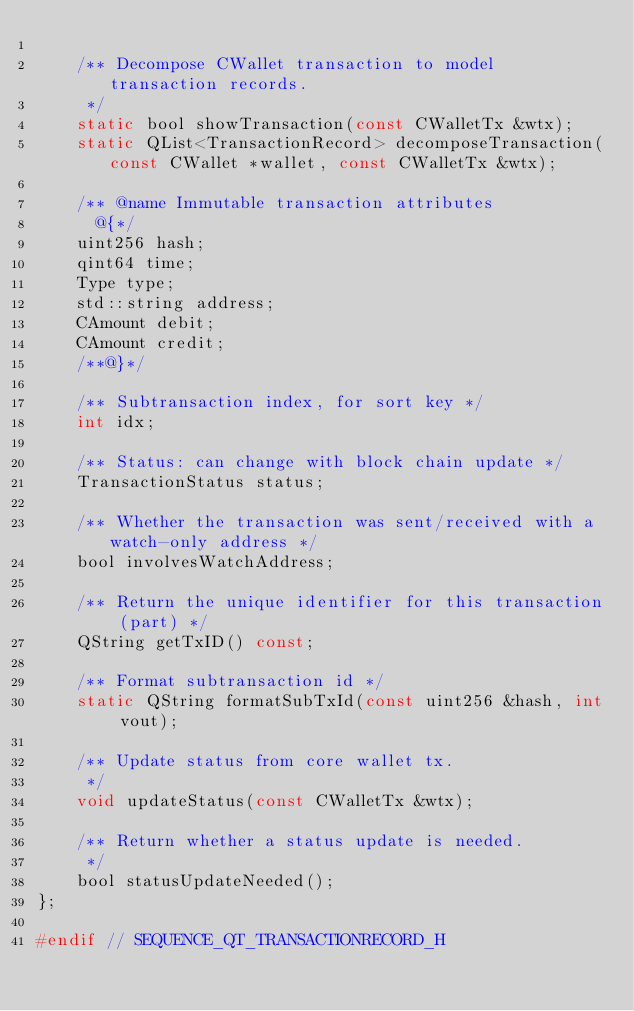Convert code to text. <code><loc_0><loc_0><loc_500><loc_500><_C_>
    /** Decompose CWallet transaction to model transaction records.
     */
    static bool showTransaction(const CWalletTx &wtx);
    static QList<TransactionRecord> decomposeTransaction(const CWallet *wallet, const CWalletTx &wtx);

    /** @name Immutable transaction attributes
      @{*/
    uint256 hash;
    qint64 time;
    Type type;
    std::string address;
    CAmount debit;
    CAmount credit;
    /**@}*/

    /** Subtransaction index, for sort key */
    int idx;

    /** Status: can change with block chain update */
    TransactionStatus status;

    /** Whether the transaction was sent/received with a watch-only address */
    bool involvesWatchAddress;

    /** Return the unique identifier for this transaction (part) */
    QString getTxID() const;

    /** Format subtransaction id */
    static QString formatSubTxId(const uint256 &hash, int vout);

    /** Update status from core wallet tx.
     */
    void updateStatus(const CWalletTx &wtx);

    /** Return whether a status update is needed.
     */
    bool statusUpdateNeeded();
};

#endif // SEQUENCE_QT_TRANSACTIONRECORD_H
</code> 